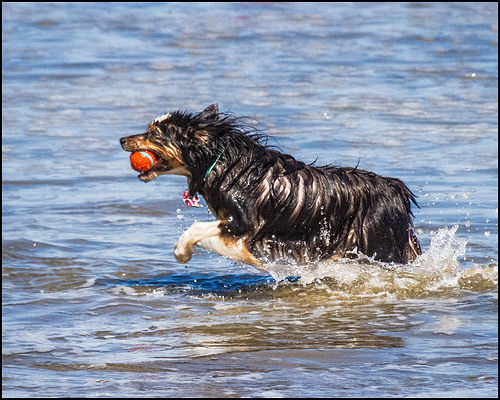<image>
Can you confirm if the ball is behind the dog? No. The ball is not behind the dog. From this viewpoint, the ball appears to be positioned elsewhere in the scene. Where is the ball in relation to the dog? Is it in the dog? Yes. The ball is contained within or inside the dog, showing a containment relationship. 